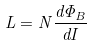<formula> <loc_0><loc_0><loc_500><loc_500>L = N \frac { d \Phi _ { B } } { d I }</formula> 